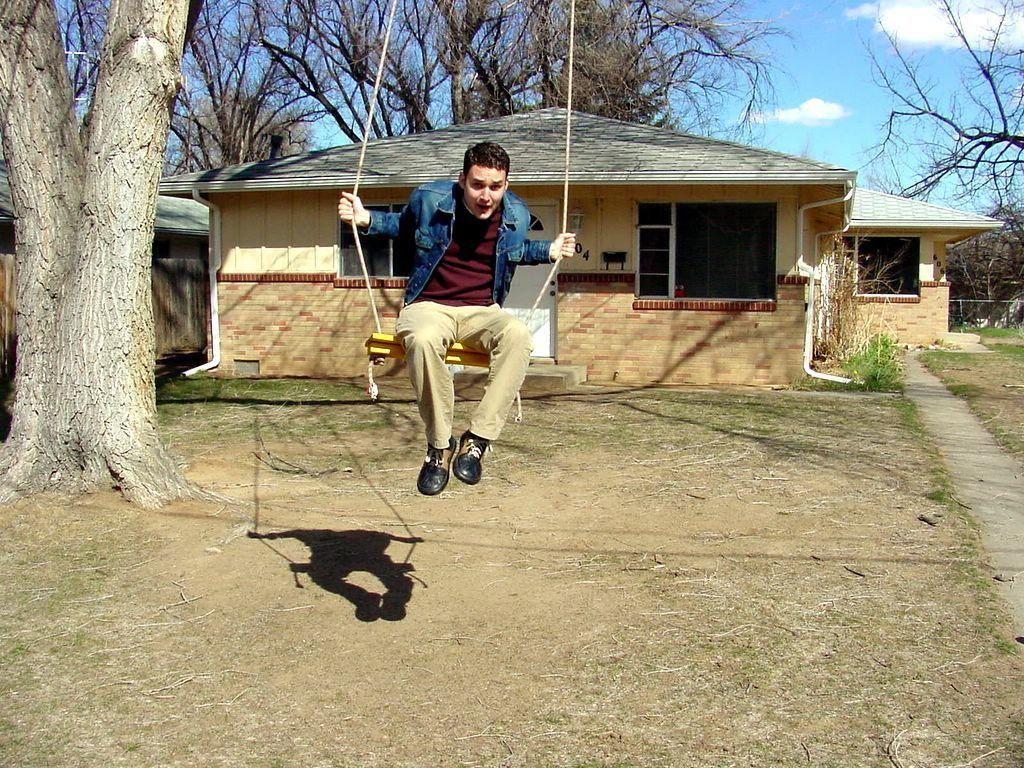What is the man in the image doing? The man is swinging on a swing. What can be seen on the left side of the image? There is a tree on the left side of the image. What is visible in the background of the image? There are houses with windows and trees visible in the background. What is the condition of the sky in the image? The sky with clouds is visible in the background. What type of substance is being argued over in the image? There is no argument or substance present in the image; it features a man swinging on a swing with a tree and houses in the background. 